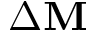<formula> <loc_0><loc_0><loc_500><loc_500>\Delta M</formula> 